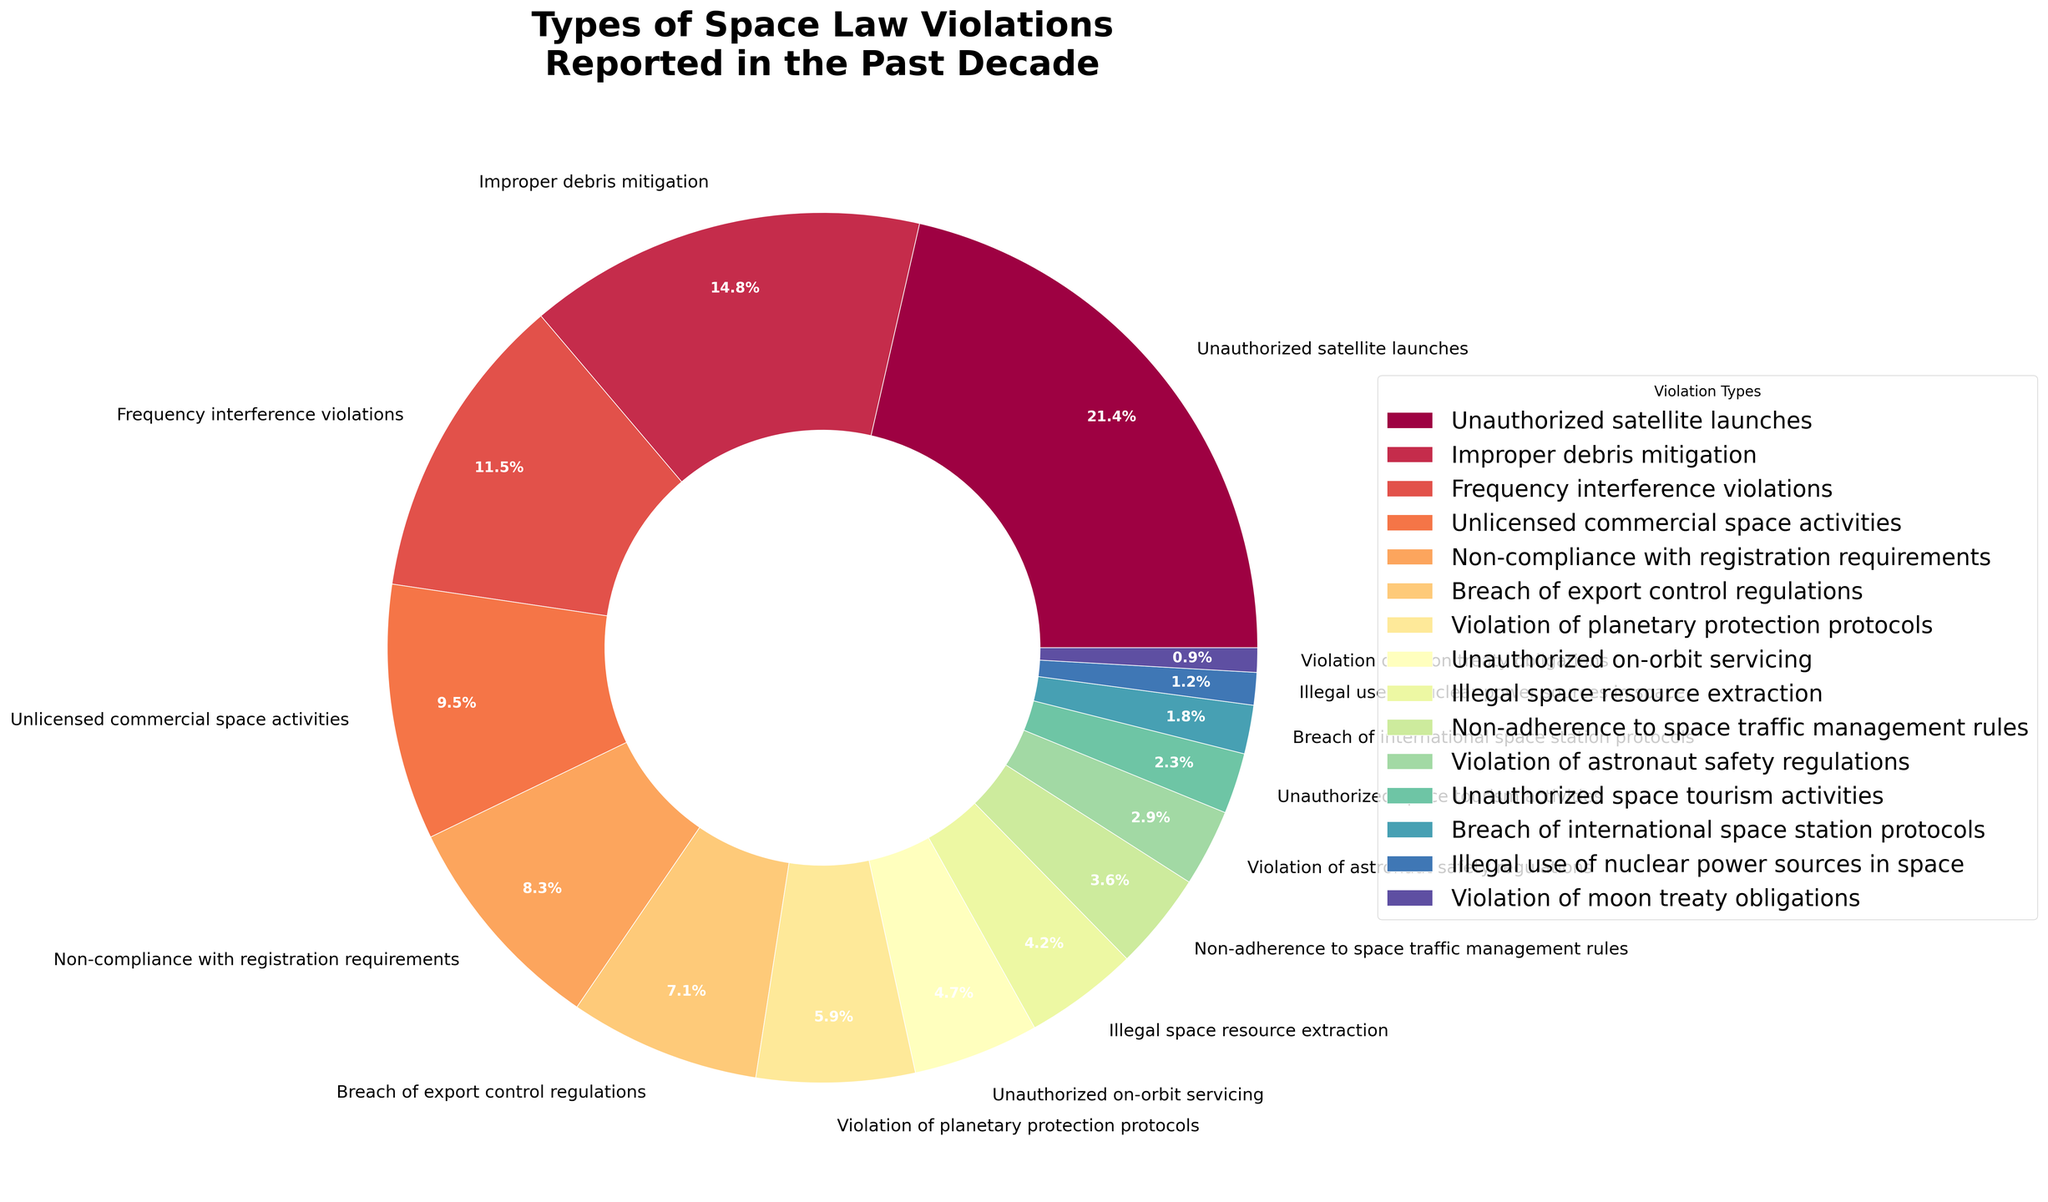What is the most common type of space law violation reported in the past decade? Reviewing the pie chart, the slice representing "Unauthorized satellite launches" is the biggest, indicating it has the highest percentage of reported cases.
Answer: Unauthorized satellite launches Which type of violation has the least number of reported cases? The smallest slice in the pie chart represents the "Violation of moon treaty obligations," indicating it has the lowest percentage of reported cases.
Answer: Violation of moon treaty obligations What is the sum of cases for improper debris mitigation and non-compliance with registration requirements? Add the number of reported cases for "Improper debris mitigation" (98) and "Non-compliance with registration requirements" (55) together: 98 + 55 = 153.
Answer: 153 Which has more reported cases: unlicensed commercial space activities or violation of planetary protection protocols? The pie chart shows "Unlicensed commercial space activities" with 63 cases and "Violation of planetary protection protocols" with 39 cases. 63 > 39.
Answer: Unlicensed commercial space activities How does the number of unauthorized on-orbit servicing violations compare to illegal space resource extraction violations? "Unauthorized on-orbit servicing" has 31 cases, and "Illegal space resource extraction" has 28 cases, which means 31 > 28.
Answer: Unauthorized on-orbit servicing What is the visual color range of the slice representing breach of international space station protocols? The color shade of the slice representing "Breach of international space station protocols" varies, generally following a gradient but often depicted in the pie chart using distinct color boundaries to ensure contrast.
Answer: Distinct color boundary How many more cases of unauthorized satellite launches are there compared to violation of astronaut safety regulations? Subtract the number of reported cases for "Violation of astronaut safety regulations" (19) from "Unauthorized satellite launches" (142): 142 - 19 = 123.
Answer: 123 Which regulatory violation involved cases that comprised between 20-30% of the total? From the chart, no single violation type falls within this percentage range, as the largest slice (Unauthorized satellite launches) constitutes less than 20% of the total cases.
Answer: None Are frequency interference violations more or less frequent than unlicensed commercial space activities? The pie chart shows that "Frequency interference violations" have 76 cases and "Unlicensed commercial space activities" have 63 cases. Therefore, 76 > 63, indicating frequency interference violations are more frequent.
Answer: More frequent Sum of the violations related to astronaut safety regulations, unauthorized space tourism activities, and breach of international space station protocols? Add up the numbers: 19 (Violation of astronaut safety regulations) + 15 (Unauthorized space tourism activities) + 12 (Breach of international space station protocols) = 46.
Answer: 46 